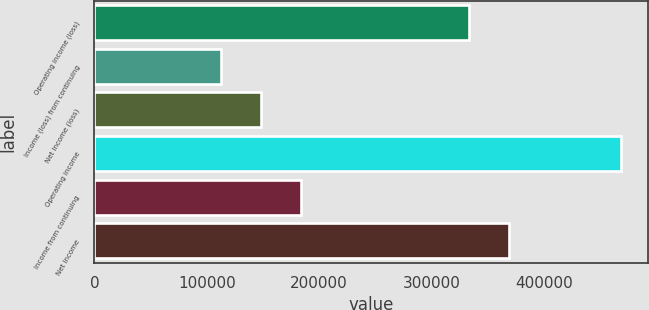Convert chart. <chart><loc_0><loc_0><loc_500><loc_500><bar_chart><fcel>Operating income (loss)<fcel>Income (loss) from continuing<fcel>Net income (loss)<fcel>Operating income<fcel>Income from continuing<fcel>Net income<nl><fcel>333784<fcel>113101<fcel>148688<fcel>468973<fcel>184275<fcel>369371<nl></chart> 